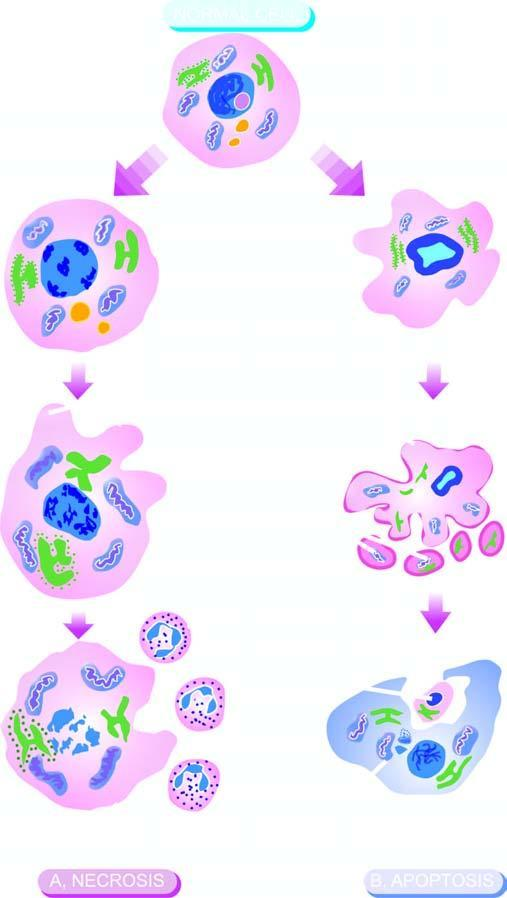does apoptosis consist of condensation of nuclear chromatin and fragmentation of the cell into membrane-bound apoptotic bodies which are engulfed by macrophages?
Answer the question using a single word or phrase. Yes 